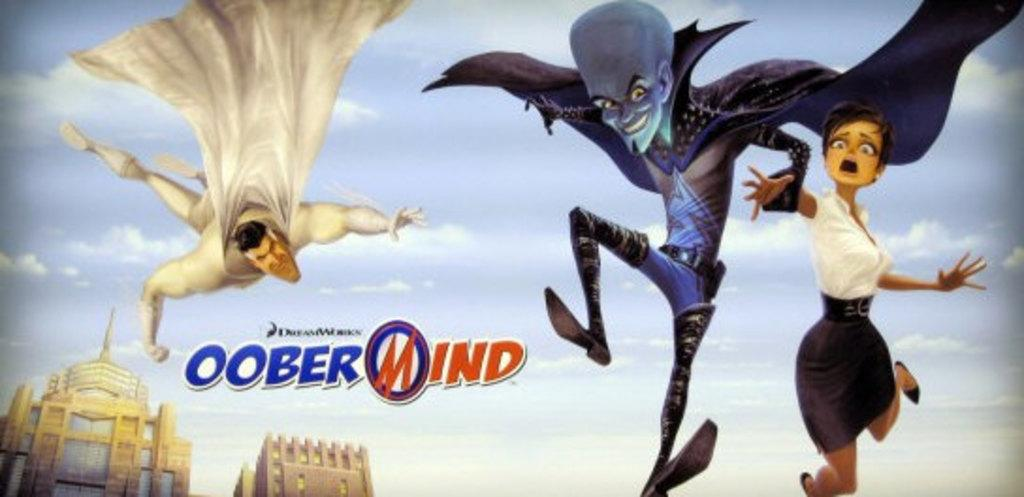<image>
Present a compact description of the photo's key features. Three cartoon characters that are in OoberMind from Dreamworks. 